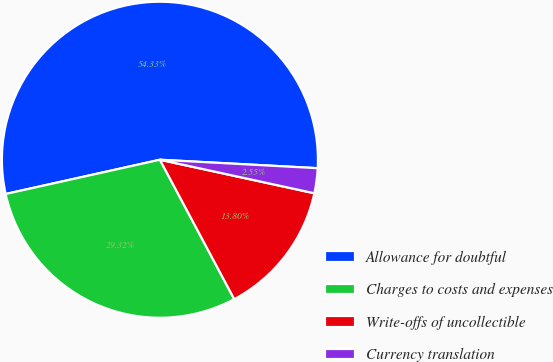Convert chart to OTSL. <chart><loc_0><loc_0><loc_500><loc_500><pie_chart><fcel>Allowance for doubtful<fcel>Charges to costs and expenses<fcel>Write-offs of uncollectible<fcel>Currency translation<nl><fcel>54.33%<fcel>29.32%<fcel>13.8%<fcel>2.55%<nl></chart> 